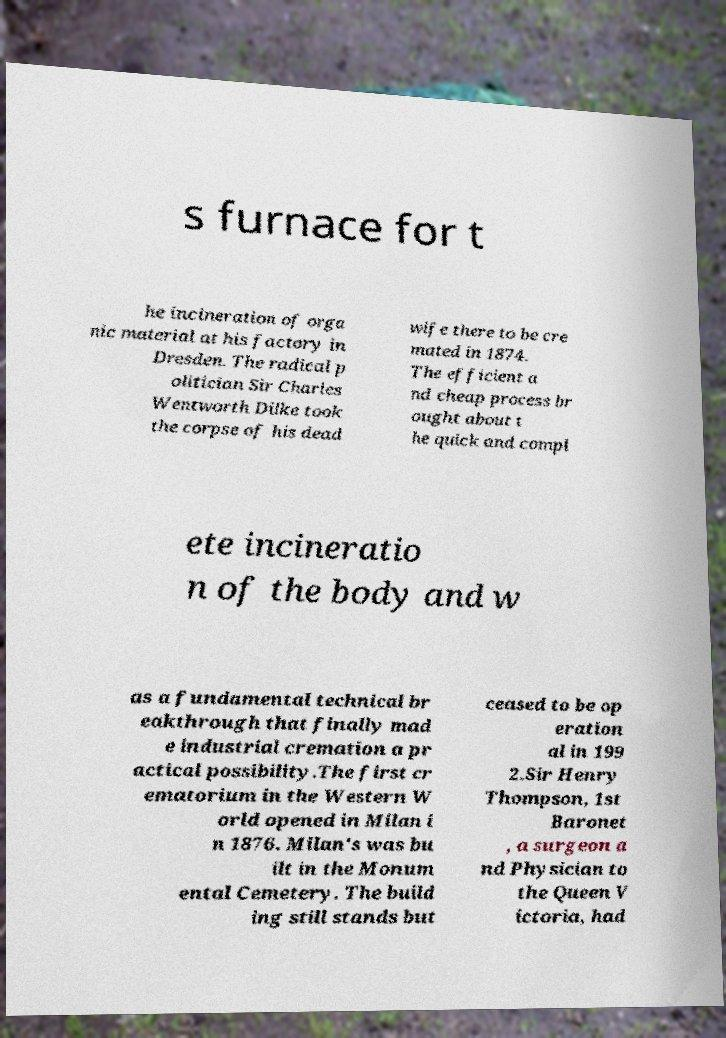Could you extract and type out the text from this image? s furnace for t he incineration of orga nic material at his factory in Dresden. The radical p olitician Sir Charles Wentworth Dilke took the corpse of his dead wife there to be cre mated in 1874. The efficient a nd cheap process br ought about t he quick and compl ete incineratio n of the body and w as a fundamental technical br eakthrough that finally mad e industrial cremation a pr actical possibility.The first cr ematorium in the Western W orld opened in Milan i n 1876. Milan's was bu ilt in the Monum ental Cemetery. The build ing still stands but ceased to be op eration al in 199 2.Sir Henry Thompson, 1st Baronet , a surgeon a nd Physician to the Queen V ictoria, had 